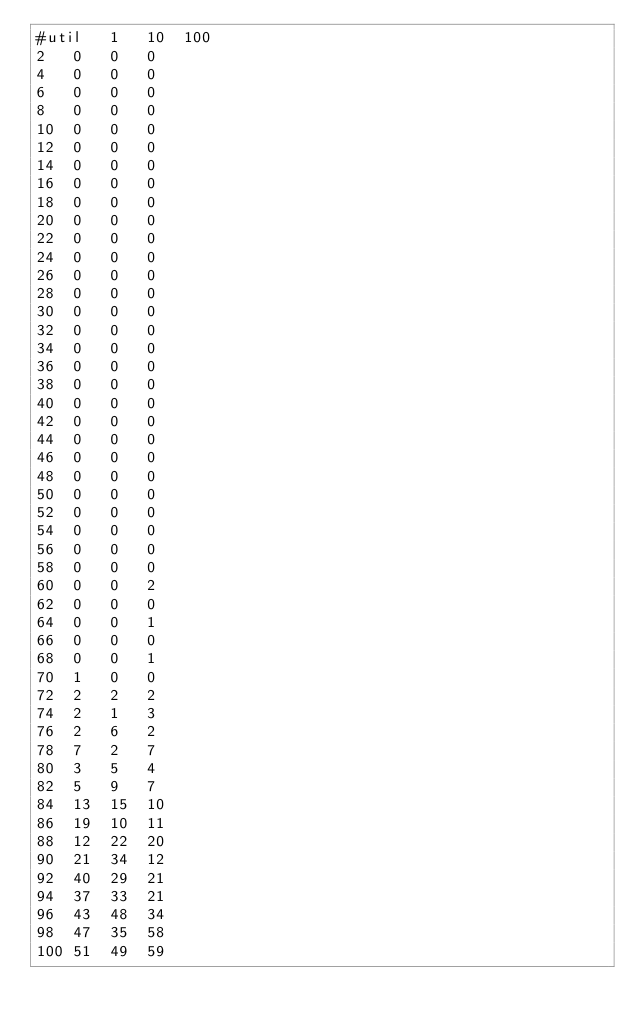Convert code to text. <code><loc_0><loc_0><loc_500><loc_500><_SQL_>#util	1	10	100
2	0	0	0
4	0	0	0
6	0	0	0
8	0	0	0
10	0	0	0
12	0	0	0
14	0	0	0
16	0	0	0
18	0	0	0
20	0	0	0
22	0	0	0
24	0	0	0
26	0	0	0
28	0	0	0
30	0	0	0
32	0	0	0
34	0	0	0
36	0	0	0
38	0	0	0
40	0	0	0
42	0	0	0
44	0	0	0
46	0	0	0
48	0	0	0
50	0	0	0
52	0	0	0
54	0	0	0
56	0	0	0
58	0	0	0
60	0	0	2
62	0	0	0
64	0	0	1
66	0	0	0
68	0	0	1
70	1	0	0
72	2	2	2
74	2	1	3
76	2	6	2
78	7	2	7
80	3	5	4
82	5	9	7
84	13	15	10
86	19	10	11
88	12	22	20
90	21	34	12
92	40	29	21
94	37	33	21
96	43	48	34
98	47	35	58
100	51	49	59
</code> 